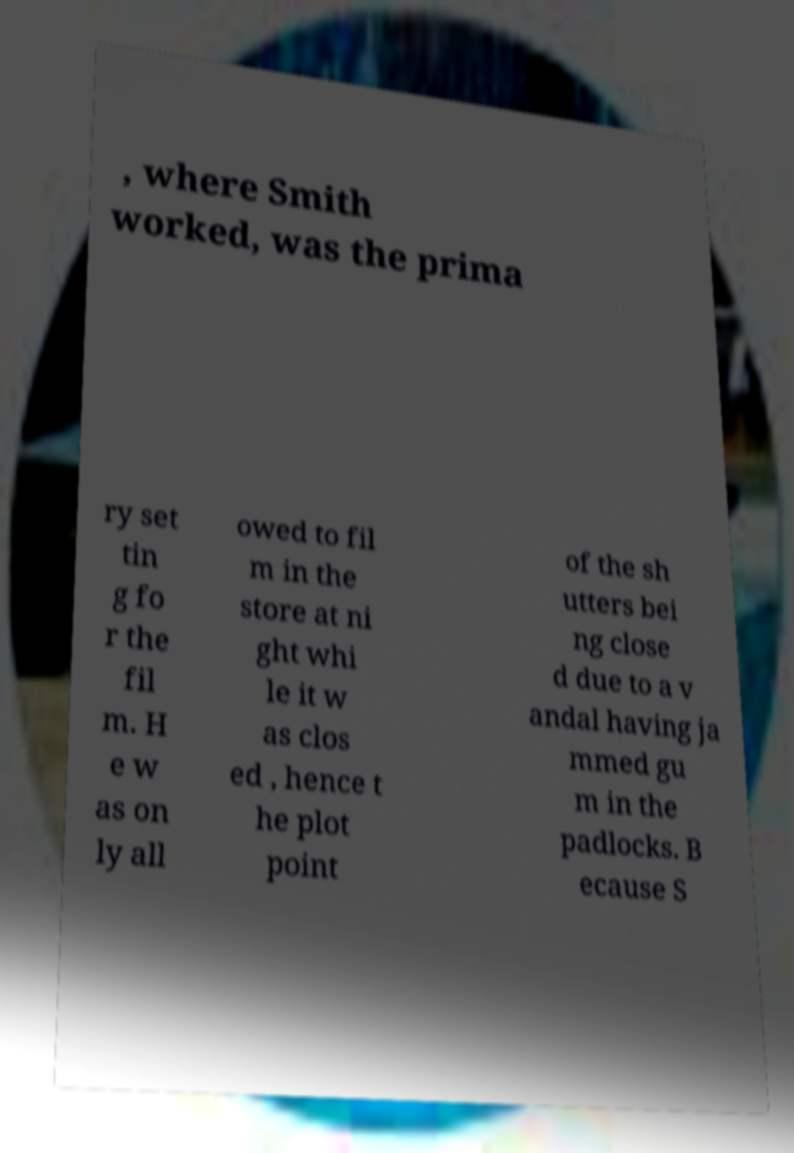There's text embedded in this image that I need extracted. Can you transcribe it verbatim? , where Smith worked, was the prima ry set tin g fo r the fil m. H e w as on ly all owed to fil m in the store at ni ght whi le it w as clos ed , hence t he plot point of the sh utters bei ng close d due to a v andal having ja mmed gu m in the padlocks. B ecause S 